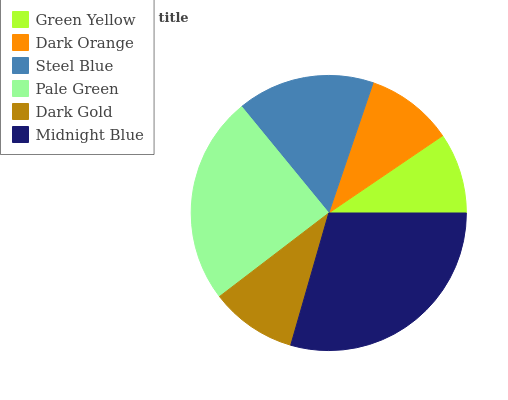Is Green Yellow the minimum?
Answer yes or no. Yes. Is Midnight Blue the maximum?
Answer yes or no. Yes. Is Dark Orange the minimum?
Answer yes or no. No. Is Dark Orange the maximum?
Answer yes or no. No. Is Dark Orange greater than Green Yellow?
Answer yes or no. Yes. Is Green Yellow less than Dark Orange?
Answer yes or no. Yes. Is Green Yellow greater than Dark Orange?
Answer yes or no. No. Is Dark Orange less than Green Yellow?
Answer yes or no. No. Is Steel Blue the high median?
Answer yes or no. Yes. Is Dark Orange the low median?
Answer yes or no. Yes. Is Green Yellow the high median?
Answer yes or no. No. Is Pale Green the low median?
Answer yes or no. No. 